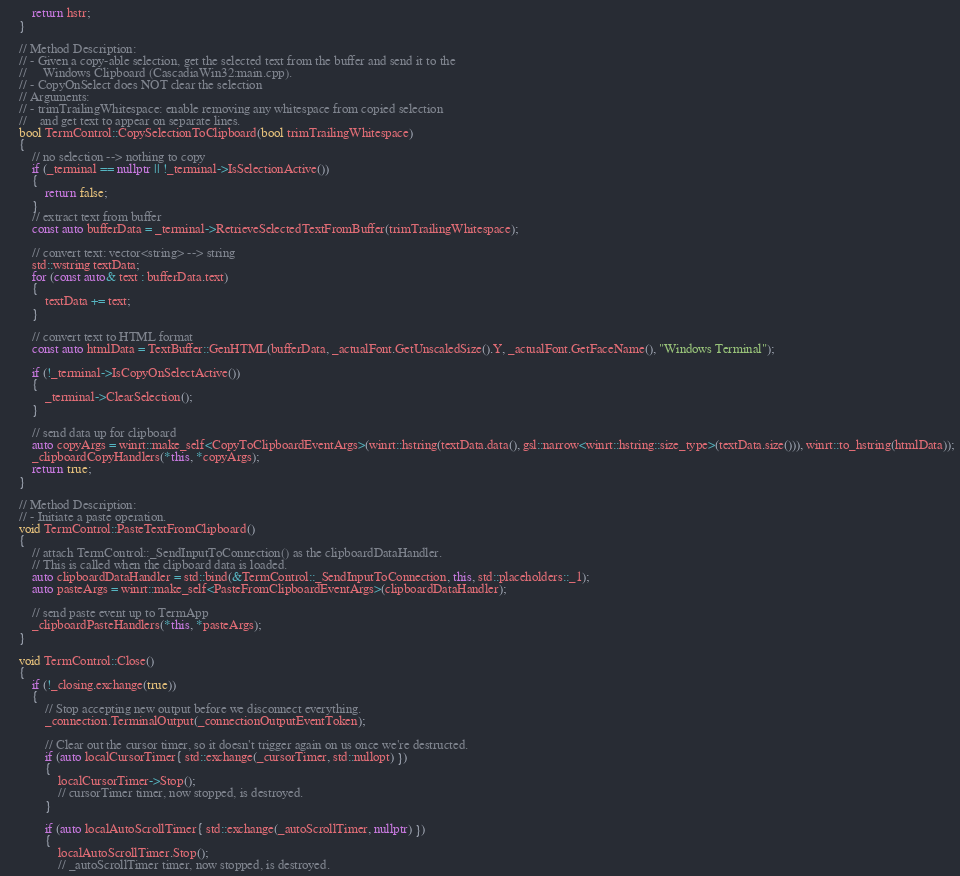Convert code to text. <code><loc_0><loc_0><loc_500><loc_500><_C++_>        return hstr;
    }

    // Method Description:
    // - Given a copy-able selection, get the selected text from the buffer and send it to the
    //     Windows Clipboard (CascadiaWin32:main.cpp).
    // - CopyOnSelect does NOT clear the selection
    // Arguments:
    // - trimTrailingWhitespace: enable removing any whitespace from copied selection
    //    and get text to appear on separate lines.
    bool TermControl::CopySelectionToClipboard(bool trimTrailingWhitespace)
    {
        // no selection --> nothing to copy
        if (_terminal == nullptr || !_terminal->IsSelectionActive())
        {
            return false;
        }
        // extract text from buffer
        const auto bufferData = _terminal->RetrieveSelectedTextFromBuffer(trimTrailingWhitespace);

        // convert text: vector<string> --> string
        std::wstring textData;
        for (const auto& text : bufferData.text)
        {
            textData += text;
        }

        // convert text to HTML format
        const auto htmlData = TextBuffer::GenHTML(bufferData, _actualFont.GetUnscaledSize().Y, _actualFont.GetFaceName(), "Windows Terminal");

        if (!_terminal->IsCopyOnSelectActive())
        {
            _terminal->ClearSelection();
        }

        // send data up for clipboard
        auto copyArgs = winrt::make_self<CopyToClipboardEventArgs>(winrt::hstring(textData.data(), gsl::narrow<winrt::hstring::size_type>(textData.size())), winrt::to_hstring(htmlData));
        _clipboardCopyHandlers(*this, *copyArgs);
        return true;
    }

    // Method Description:
    // - Initiate a paste operation.
    void TermControl::PasteTextFromClipboard()
    {
        // attach TermControl::_SendInputToConnection() as the clipboardDataHandler.
        // This is called when the clipboard data is loaded.
        auto clipboardDataHandler = std::bind(&TermControl::_SendInputToConnection, this, std::placeholders::_1);
        auto pasteArgs = winrt::make_self<PasteFromClipboardEventArgs>(clipboardDataHandler);

        // send paste event up to TermApp
        _clipboardPasteHandlers(*this, *pasteArgs);
    }

    void TermControl::Close()
    {
        if (!_closing.exchange(true))
        {
            // Stop accepting new output before we disconnect everything.
            _connection.TerminalOutput(_connectionOutputEventToken);

            // Clear out the cursor timer, so it doesn't trigger again on us once we're destructed.
            if (auto localCursorTimer{ std::exchange(_cursorTimer, std::nullopt) })
            {
                localCursorTimer->Stop();
                // cursorTimer timer, now stopped, is destroyed.
            }

            if (auto localAutoScrollTimer{ std::exchange(_autoScrollTimer, nullptr) })
            {
                localAutoScrollTimer.Stop();
                // _autoScrollTimer timer, now stopped, is destroyed.</code> 